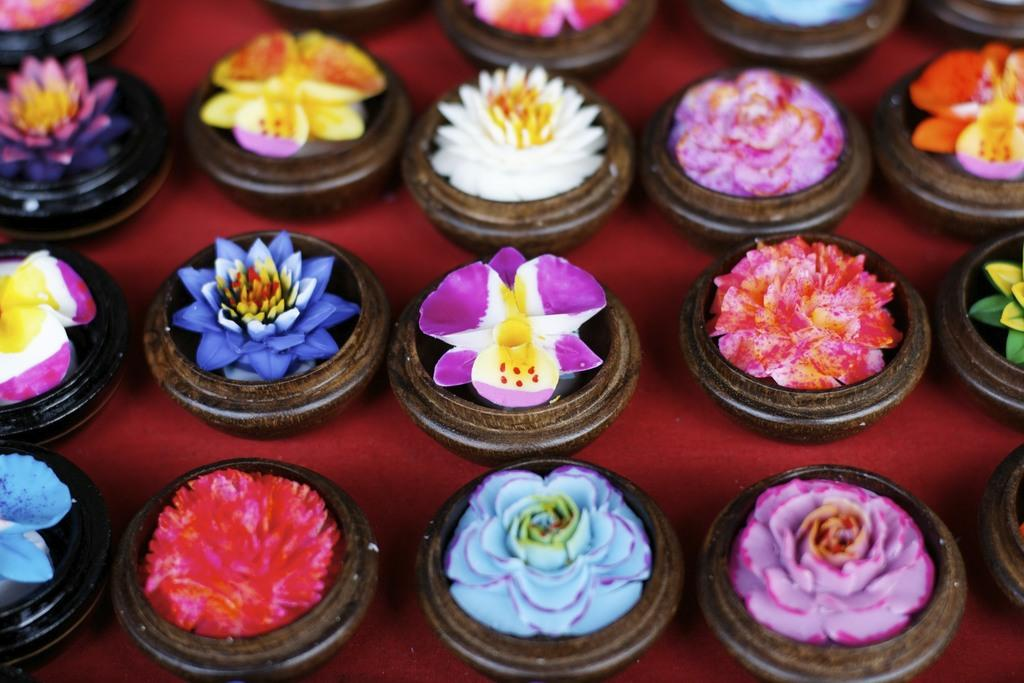What types of plants are in the image? There are different types of flowers in the image. How are the flowers arranged or displayed? The flowers are placed in small bowls. Where are the small bowls with flowers located? The small bowls with flowers are on a table. What type of belief is represented by the flowers in the image? There is no indication of any belief represented by the flowers in the image. 